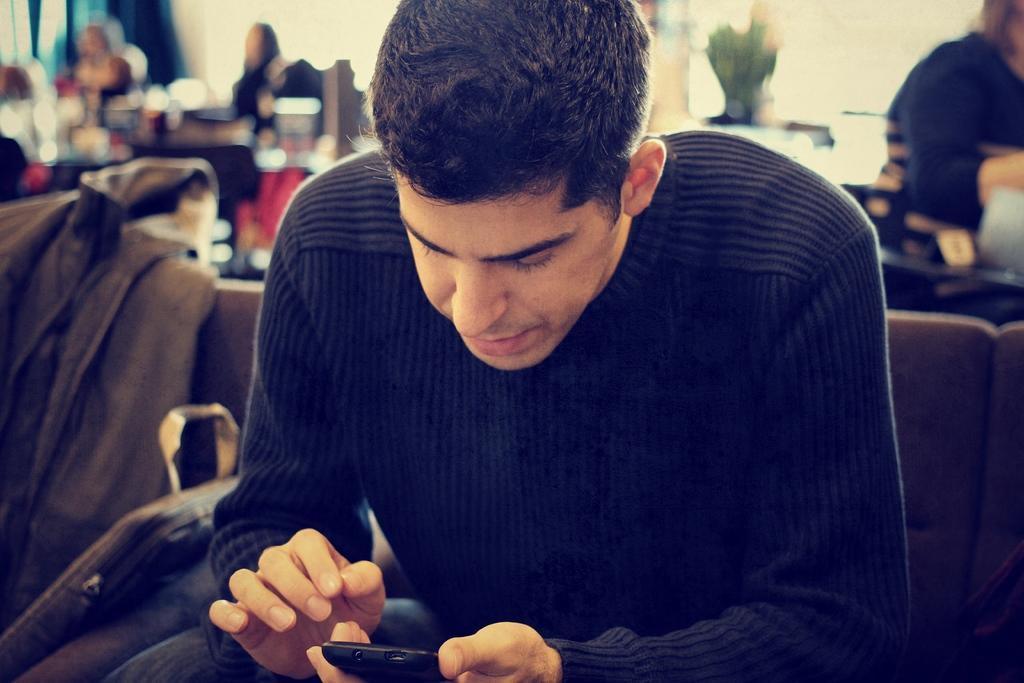How would you summarize this image in a sentence or two? In this image we can see persons sitting on the chairs. In addition to this we can see backpacks, jackets and plants. 